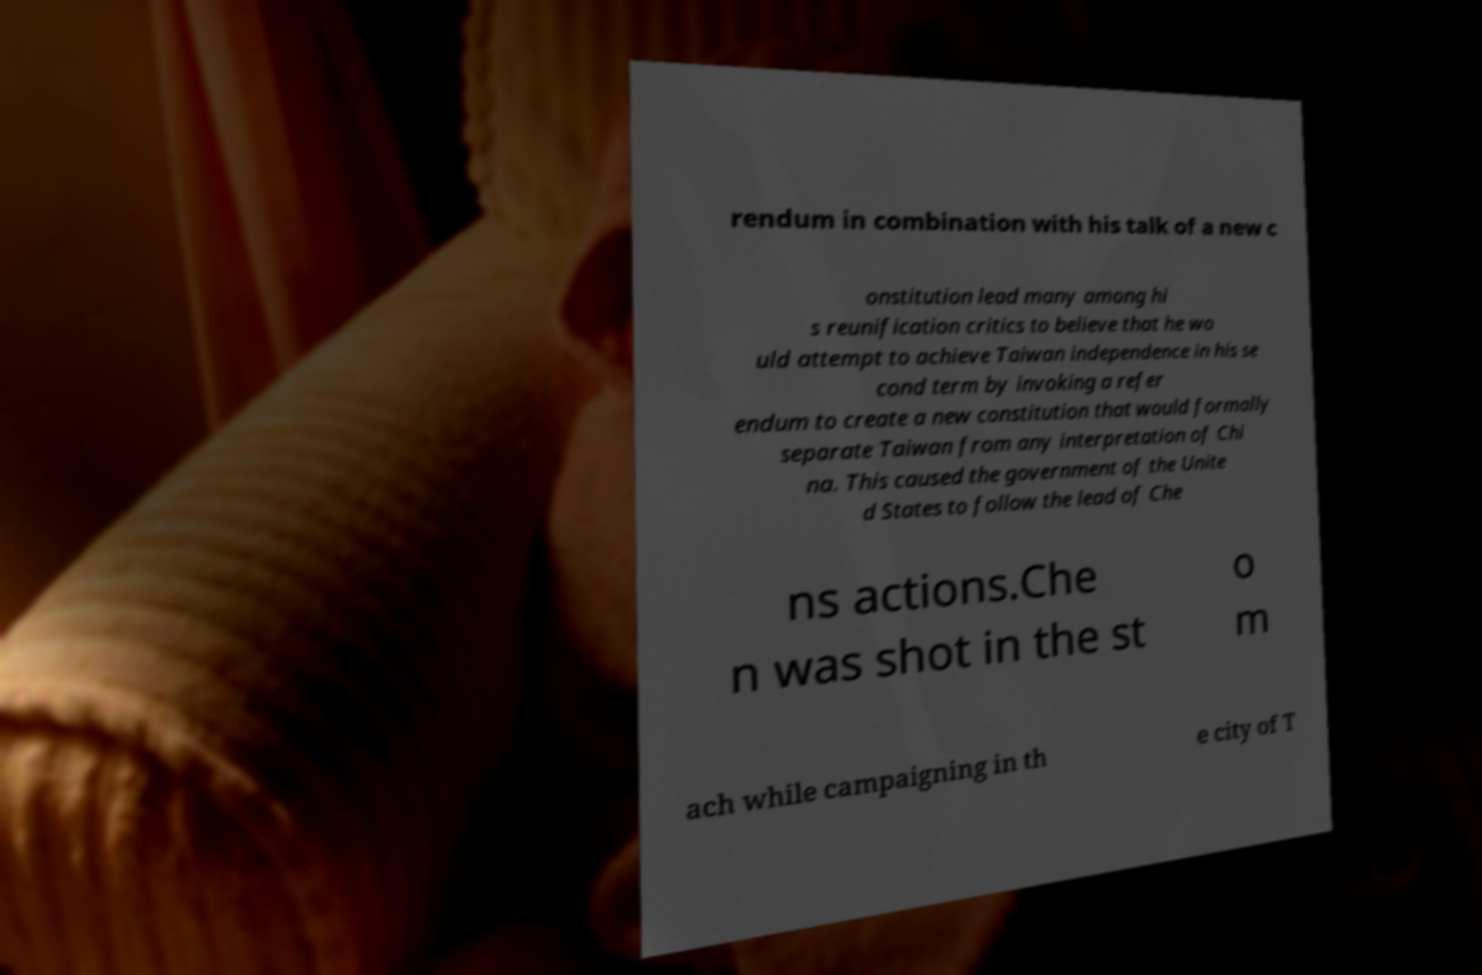Could you extract and type out the text from this image? rendum in combination with his talk of a new c onstitution lead many among hi s reunification critics to believe that he wo uld attempt to achieve Taiwan independence in his se cond term by invoking a refer endum to create a new constitution that would formally separate Taiwan from any interpretation of Chi na. This caused the government of the Unite d States to follow the lead of Che ns actions.Che n was shot in the st o m ach while campaigning in th e city of T 